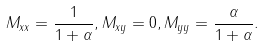<formula> <loc_0><loc_0><loc_500><loc_500>M _ { x x } = \frac { 1 } { 1 + \alpha } , M _ { x y } = 0 , M _ { y y } = \frac { \alpha } { 1 + \alpha } .</formula> 